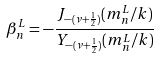<formula> <loc_0><loc_0><loc_500><loc_500>\beta _ { n } ^ { L } = - \frac { J _ { - ( \nu + \frac { 1 } { 2 } ) } ( m _ { n } ^ { L } / k ) } { Y _ { - ( \nu + \frac { 1 } { 2 } ) } ( m _ { n } ^ { L } / k ) }</formula> 